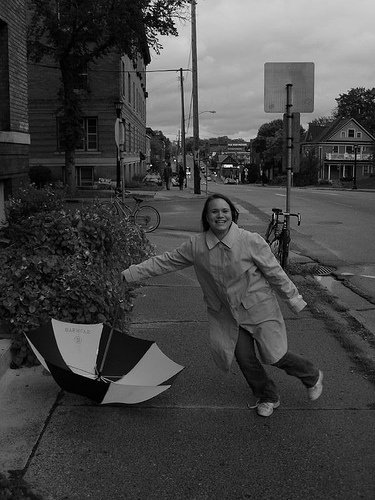Describe the objects in this image and their specific colors. I can see people in black and gray tones, umbrella in black, gray, and lightgray tones, bicycle in gray and black tones, bicycle in black, gray, and lightgray tones, and stop sign in gray and black tones in this image. 